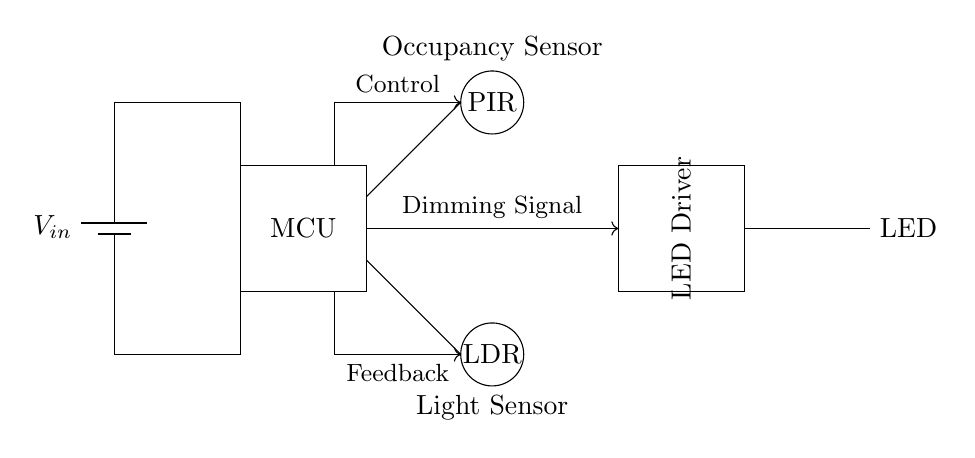What is the function of the occupancy sensor in this circuit? The occupancy sensor detects whether a person is present in the area, allowing the circuit to control lighting based on occupancy. This affects the overall energy efficiency and user convenience.
Answer: detects presence What is the role of the LED driver in this circuit? The LED driver regulates the power supply to the LED, ensuring that it receives the correct current for optimal brightness and functionality. It controls the dimming effect based on the signals provided by the microcontroller.
Answer: regulates power How many different types of sensors are present in this circuit? There are two types of sensors: an occupancy sensor (PIR) and a light sensor (LDR). Together, they facilitate intelligent lighting control based on environmental conditions.
Answer: two What is the voltage source in this circuit? The voltage source is represented by the battery labeled V_in, which supplies power to the entire circuit. The relevant connections to components are made from this source.
Answer: V_in What is the purpose of the dimming signal in the circuit? The dimming signal adjusts the brightness of the LED based on feedback from the light sensor, allowing for adaptive lighting levels depending on the ambient light conditions and occupancy status.
Answer: adjust brightness Which component receives feedback signals in this circuit? The microcontroller (MCU) receives feedback signals from the light sensor (LDR) and the occupancy sensor (PIR), processing this information to manage the LED driver operation.
Answer: microcontroller 